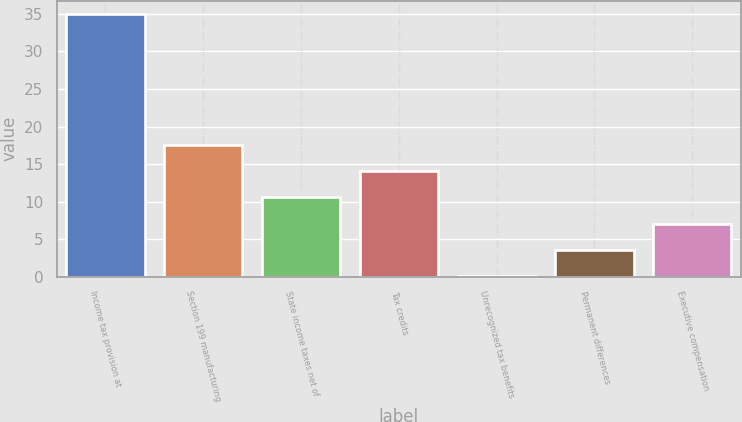Convert chart to OTSL. <chart><loc_0><loc_0><loc_500><loc_500><bar_chart><fcel>Income tax provision at<fcel>Section 199 manufacturing<fcel>State income taxes net of<fcel>Tax credits<fcel>Unrecognized tax benefits<fcel>Permanent differences<fcel>Executive compensation<nl><fcel>35<fcel>17.55<fcel>10.57<fcel>14.06<fcel>0.1<fcel>3.59<fcel>7.08<nl></chart> 